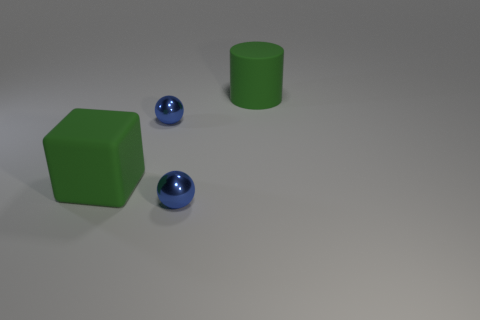There is a big rubber cylinder right of the big rubber cube; does it have the same color as the big cube?
Offer a very short reply. Yes. Does the block have the same color as the matte cylinder?
Your answer should be compact. Yes. What material is the large thing that is the same color as the cube?
Your response must be concise. Rubber. How many matte blocks are the same color as the big matte cylinder?
Offer a terse response. 1. What number of cubes are small blue metal things or large green rubber things?
Ensure brevity in your answer.  1. What number of things are either large brown cylinders or large green matte objects?
Provide a short and direct response. 2. There is a blue metallic sphere that is in front of the green rubber cube; is it the same size as the blue metallic sphere behind the matte block?
Offer a very short reply. Yes. How many other things are there of the same material as the large cube?
Ensure brevity in your answer.  1. Is the number of big green rubber cylinders behind the cylinder greater than the number of blocks that are behind the cube?
Offer a terse response. No. There is a large block in front of the green rubber cylinder; what material is it?
Offer a terse response. Rubber. 